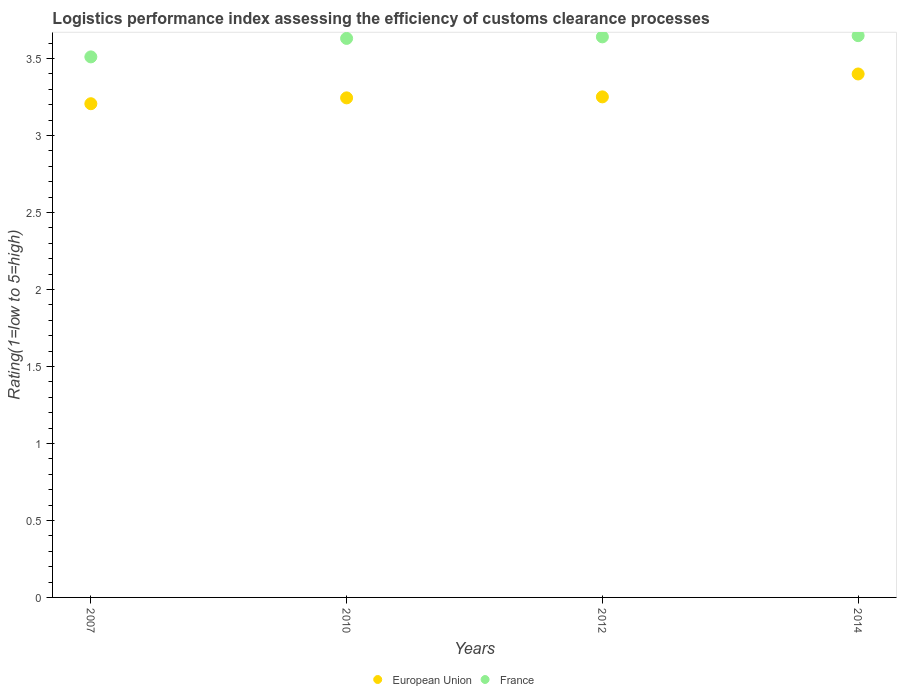What is the Logistic performance index in France in 2010?
Make the answer very short. 3.63. Across all years, what is the maximum Logistic performance index in France?
Offer a very short reply. 3.65. Across all years, what is the minimum Logistic performance index in France?
Your response must be concise. 3.51. In which year was the Logistic performance index in European Union minimum?
Your answer should be very brief. 2007. What is the total Logistic performance index in European Union in the graph?
Provide a succinct answer. 13.1. What is the difference between the Logistic performance index in European Union in 2007 and that in 2010?
Ensure brevity in your answer.  -0.04. What is the difference between the Logistic performance index in European Union in 2010 and the Logistic performance index in France in 2007?
Give a very brief answer. -0.27. What is the average Logistic performance index in European Union per year?
Offer a terse response. 3.27. In the year 2010, what is the difference between the Logistic performance index in France and Logistic performance index in European Union?
Give a very brief answer. 0.39. What is the ratio of the Logistic performance index in European Union in 2007 to that in 2014?
Give a very brief answer. 0.94. Is the Logistic performance index in European Union in 2010 less than that in 2014?
Keep it short and to the point. Yes. What is the difference between the highest and the second highest Logistic performance index in European Union?
Provide a succinct answer. 0.15. What is the difference between the highest and the lowest Logistic performance index in European Union?
Offer a very short reply. 0.19. Is the sum of the Logistic performance index in European Union in 2010 and 2014 greater than the maximum Logistic performance index in France across all years?
Keep it short and to the point. Yes. Is the Logistic performance index in France strictly greater than the Logistic performance index in European Union over the years?
Your answer should be very brief. Yes. How many years are there in the graph?
Ensure brevity in your answer.  4. Does the graph contain any zero values?
Make the answer very short. No. What is the title of the graph?
Offer a terse response. Logistics performance index assessing the efficiency of customs clearance processes. What is the label or title of the X-axis?
Your answer should be very brief. Years. What is the label or title of the Y-axis?
Your response must be concise. Rating(1=low to 5=high). What is the Rating(1=low to 5=high) of European Union in 2007?
Make the answer very short. 3.21. What is the Rating(1=low to 5=high) of France in 2007?
Make the answer very short. 3.51. What is the Rating(1=low to 5=high) of European Union in 2010?
Ensure brevity in your answer.  3.24. What is the Rating(1=low to 5=high) in France in 2010?
Keep it short and to the point. 3.63. What is the Rating(1=low to 5=high) of European Union in 2012?
Offer a very short reply. 3.25. What is the Rating(1=low to 5=high) in France in 2012?
Ensure brevity in your answer.  3.64. What is the Rating(1=low to 5=high) of European Union in 2014?
Make the answer very short. 3.4. What is the Rating(1=low to 5=high) in France in 2014?
Your answer should be compact. 3.65. Across all years, what is the maximum Rating(1=low to 5=high) of European Union?
Give a very brief answer. 3.4. Across all years, what is the maximum Rating(1=low to 5=high) in France?
Keep it short and to the point. 3.65. Across all years, what is the minimum Rating(1=low to 5=high) in European Union?
Keep it short and to the point. 3.21. Across all years, what is the minimum Rating(1=low to 5=high) of France?
Provide a succinct answer. 3.51. What is the total Rating(1=low to 5=high) in European Union in the graph?
Offer a very short reply. 13.1. What is the total Rating(1=low to 5=high) in France in the graph?
Make the answer very short. 14.43. What is the difference between the Rating(1=low to 5=high) in European Union in 2007 and that in 2010?
Ensure brevity in your answer.  -0.04. What is the difference between the Rating(1=low to 5=high) in France in 2007 and that in 2010?
Ensure brevity in your answer.  -0.12. What is the difference between the Rating(1=low to 5=high) of European Union in 2007 and that in 2012?
Offer a terse response. -0.04. What is the difference between the Rating(1=low to 5=high) in France in 2007 and that in 2012?
Your answer should be very brief. -0.13. What is the difference between the Rating(1=low to 5=high) in European Union in 2007 and that in 2014?
Offer a very short reply. -0.19. What is the difference between the Rating(1=low to 5=high) in France in 2007 and that in 2014?
Your answer should be very brief. -0.14. What is the difference between the Rating(1=low to 5=high) of European Union in 2010 and that in 2012?
Provide a succinct answer. -0.01. What is the difference between the Rating(1=low to 5=high) in France in 2010 and that in 2012?
Keep it short and to the point. -0.01. What is the difference between the Rating(1=low to 5=high) of European Union in 2010 and that in 2014?
Offer a terse response. -0.16. What is the difference between the Rating(1=low to 5=high) of France in 2010 and that in 2014?
Provide a short and direct response. -0.02. What is the difference between the Rating(1=low to 5=high) of European Union in 2012 and that in 2014?
Make the answer very short. -0.15. What is the difference between the Rating(1=low to 5=high) in France in 2012 and that in 2014?
Provide a short and direct response. -0.01. What is the difference between the Rating(1=low to 5=high) in European Union in 2007 and the Rating(1=low to 5=high) in France in 2010?
Provide a succinct answer. -0.42. What is the difference between the Rating(1=low to 5=high) of European Union in 2007 and the Rating(1=low to 5=high) of France in 2012?
Give a very brief answer. -0.43. What is the difference between the Rating(1=low to 5=high) in European Union in 2007 and the Rating(1=low to 5=high) in France in 2014?
Make the answer very short. -0.44. What is the difference between the Rating(1=low to 5=high) in European Union in 2010 and the Rating(1=low to 5=high) in France in 2012?
Ensure brevity in your answer.  -0.4. What is the difference between the Rating(1=low to 5=high) of European Union in 2010 and the Rating(1=low to 5=high) of France in 2014?
Offer a very short reply. -0.4. What is the difference between the Rating(1=low to 5=high) of European Union in 2012 and the Rating(1=low to 5=high) of France in 2014?
Make the answer very short. -0.4. What is the average Rating(1=low to 5=high) of European Union per year?
Your answer should be compact. 3.27. What is the average Rating(1=low to 5=high) of France per year?
Give a very brief answer. 3.61. In the year 2007, what is the difference between the Rating(1=low to 5=high) of European Union and Rating(1=low to 5=high) of France?
Offer a terse response. -0.3. In the year 2010, what is the difference between the Rating(1=low to 5=high) in European Union and Rating(1=low to 5=high) in France?
Provide a succinct answer. -0.39. In the year 2012, what is the difference between the Rating(1=low to 5=high) of European Union and Rating(1=low to 5=high) of France?
Offer a very short reply. -0.39. In the year 2014, what is the difference between the Rating(1=low to 5=high) of European Union and Rating(1=low to 5=high) of France?
Offer a very short reply. -0.25. What is the ratio of the Rating(1=low to 5=high) in European Union in 2007 to that in 2010?
Give a very brief answer. 0.99. What is the ratio of the Rating(1=low to 5=high) in France in 2007 to that in 2010?
Provide a short and direct response. 0.97. What is the ratio of the Rating(1=low to 5=high) of European Union in 2007 to that in 2012?
Your answer should be compact. 0.99. What is the ratio of the Rating(1=low to 5=high) of European Union in 2007 to that in 2014?
Your response must be concise. 0.94. What is the ratio of the Rating(1=low to 5=high) in France in 2007 to that in 2014?
Ensure brevity in your answer.  0.96. What is the ratio of the Rating(1=low to 5=high) in France in 2010 to that in 2012?
Provide a short and direct response. 1. What is the ratio of the Rating(1=low to 5=high) in European Union in 2010 to that in 2014?
Ensure brevity in your answer.  0.95. What is the ratio of the Rating(1=low to 5=high) of European Union in 2012 to that in 2014?
Give a very brief answer. 0.96. What is the ratio of the Rating(1=low to 5=high) in France in 2012 to that in 2014?
Offer a very short reply. 1. What is the difference between the highest and the second highest Rating(1=low to 5=high) of European Union?
Offer a terse response. 0.15. What is the difference between the highest and the second highest Rating(1=low to 5=high) of France?
Your answer should be very brief. 0.01. What is the difference between the highest and the lowest Rating(1=low to 5=high) of European Union?
Keep it short and to the point. 0.19. What is the difference between the highest and the lowest Rating(1=low to 5=high) in France?
Keep it short and to the point. 0.14. 